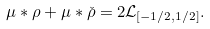Convert formula to latex. <formula><loc_0><loc_0><loc_500><loc_500>\mu \ast \rho + \mu \ast \check { \rho } = 2 { \mathcal { L } } _ { [ - 1 / 2 , 1 / 2 ] } .</formula> 